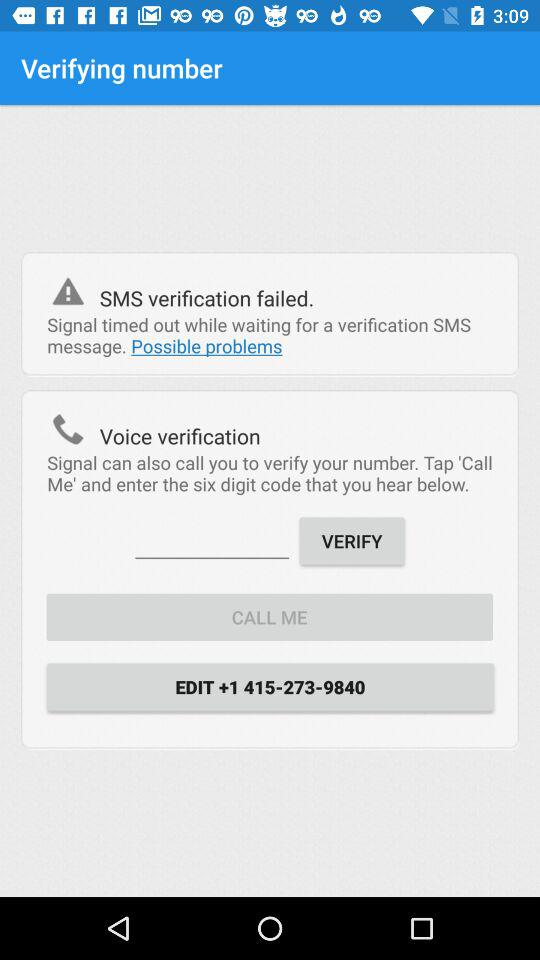What is the number? The number is +1 415-273-9840. 